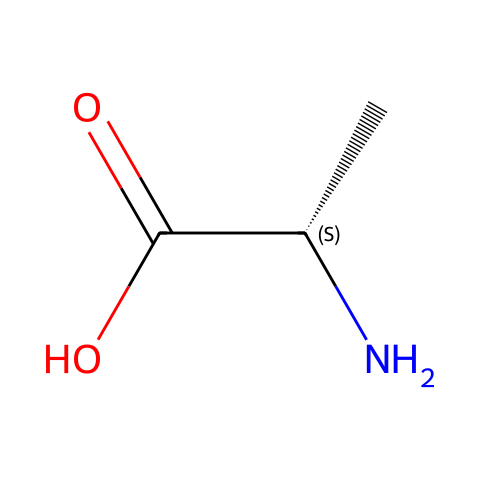What is the molecular formula of this compound? The molecular formula can be determined by counting the number of each type of atom in the SMILES representation. In this case, there is 1 nitrogen (N), 5 carbons (C), 9 hydrogens (H), and 2 oxygens (O), leading to the formula C5H11NO2.
Answer: C5H11NO2 How many chiral centers are present in this compound? A chiral center is typically a carbon atom that is attached to four different substituents. In the given SMILES representation, there is one carbon atom (the one represented as C@@H) that has four different groups (the amino group, the carboxylic acid, a hydrogen atom, and a side chain), indicating one chiral center.
Answer: 1 What functional groups are present in this compound? By analyzing the SMILES, we can identify functional groups. There is an amino group (-NH2), a carboxylic acid group (-COOH), and a carbon chain (the presence of the carbon atoms suggest -C). Therefore, the functional groups are amino and carboxylic acid.
Answer: amino and carboxylic acid Which amino acid does this compound represent? This compound is structurally identical to L-alanine, which is an amino acid commonly found in proteins and has the specific structure represented in the SMILES.
Answer: L-alanine What makes this compound chiral? Chirality is due to the presence of a carbon atom bonded to four different groups, resulting in non-superimposable mirror images. In this case, the carbon with an attached amino group, carboxyl group, hydrogen, and side chain exhibits this property, thus making the compound chiral.
Answer: one carbon atom How many hydrogen atoms are bonded to the chiral center? The chiral center is the carbon that is attached to four different groups (as identified earlier). Since it must have a total of four bonds and one is a hydrogen, there is only one hydrogen atom directly bonded to the chiral center.
Answer: 1 What type of stereochemistry is indicated by the SMILES notation? The SMILES uses "@@" to denote stereochemistry, specifically indicating the configuration around the chiral carbon. In this case, it's L configuration (or S configuration based on Cahn-Ingold-Prelog priority rules) since it represents L-amino acids.
Answer: L configuration 